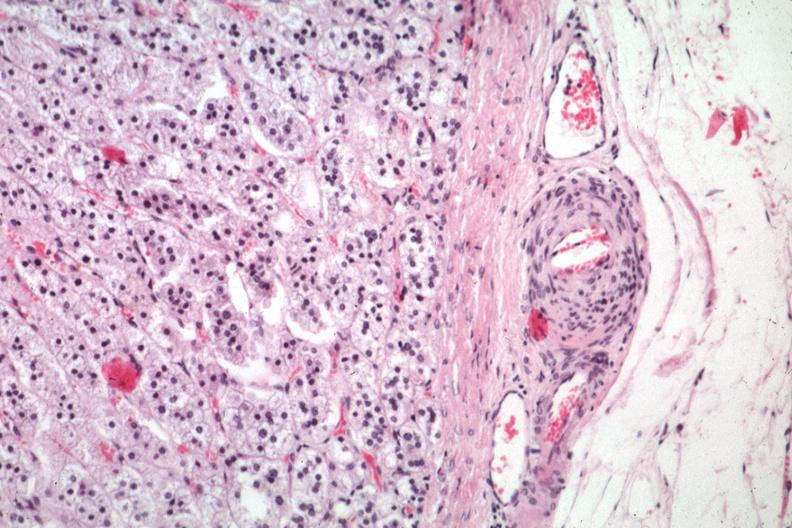s adrenal present?
Answer the question using a single word or phrase. Yes 